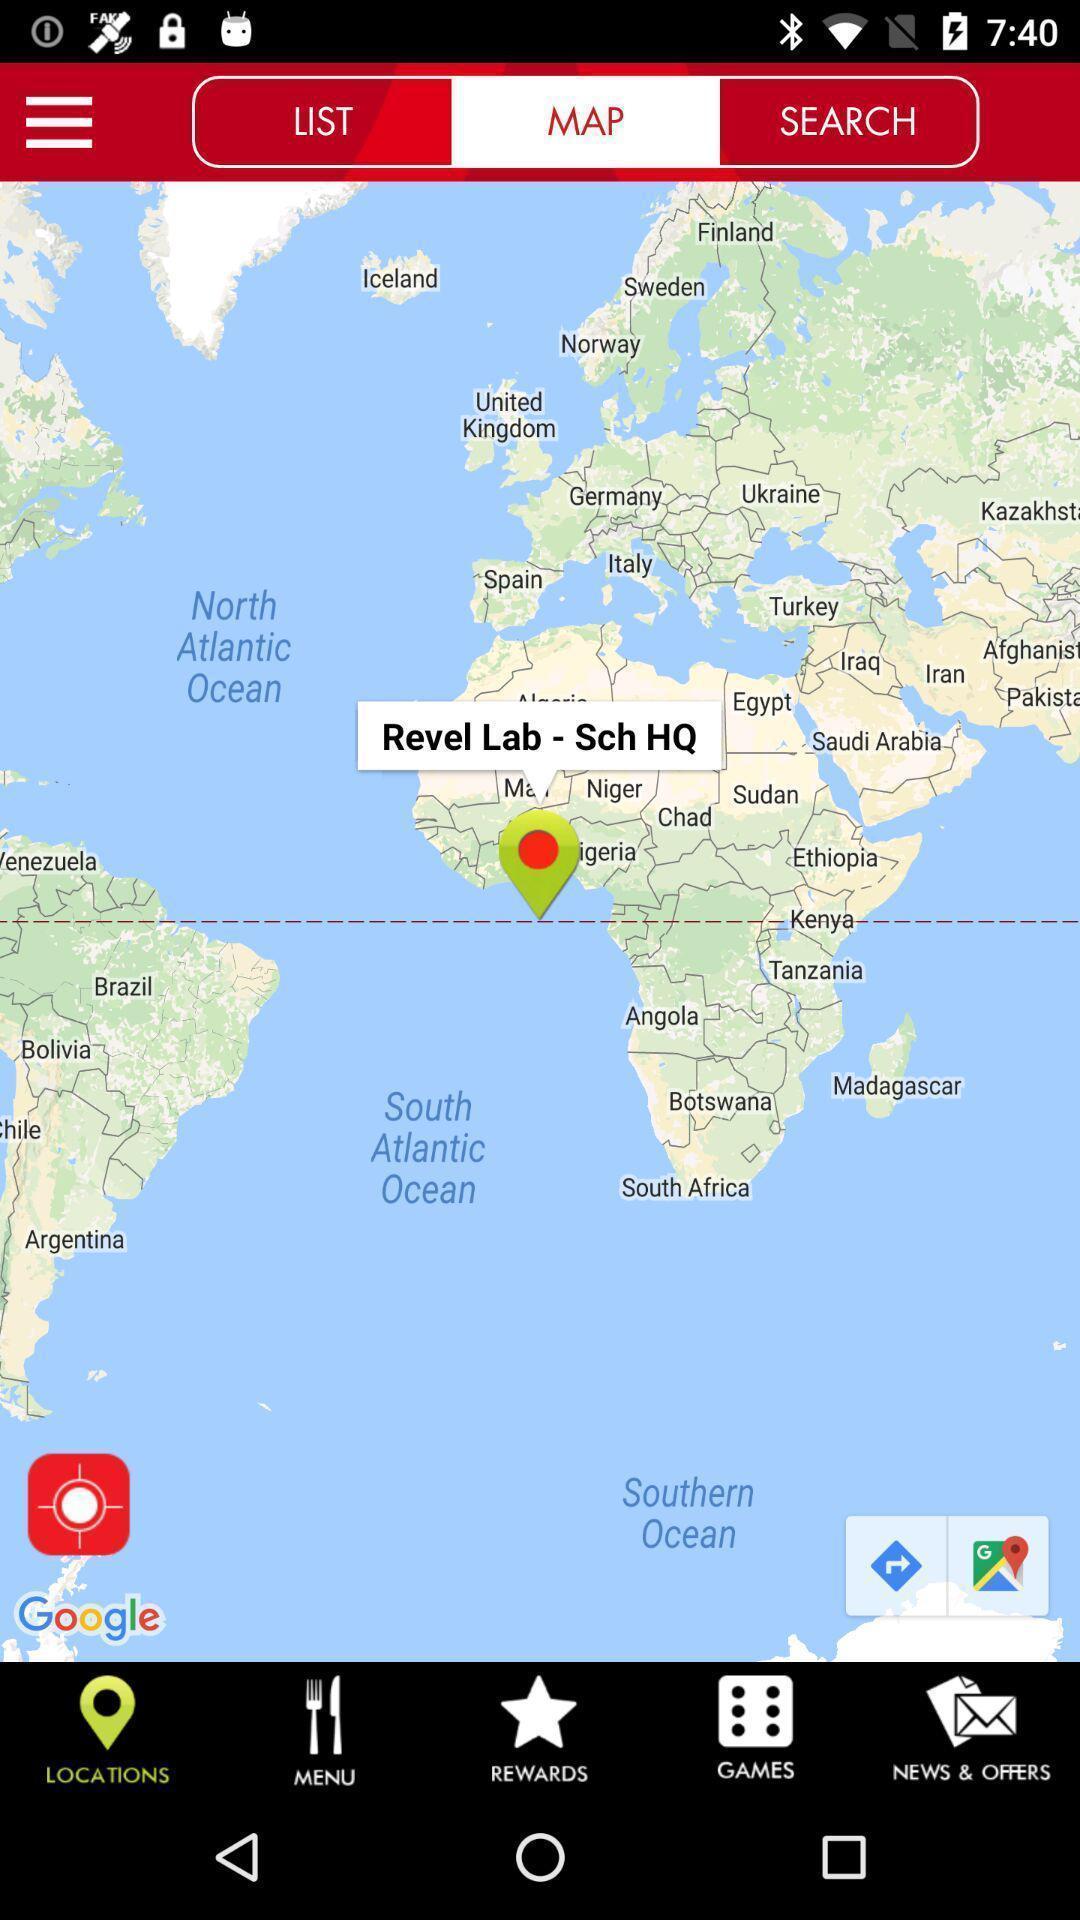Explain what's happening in this screen capture. Screen showing map. 